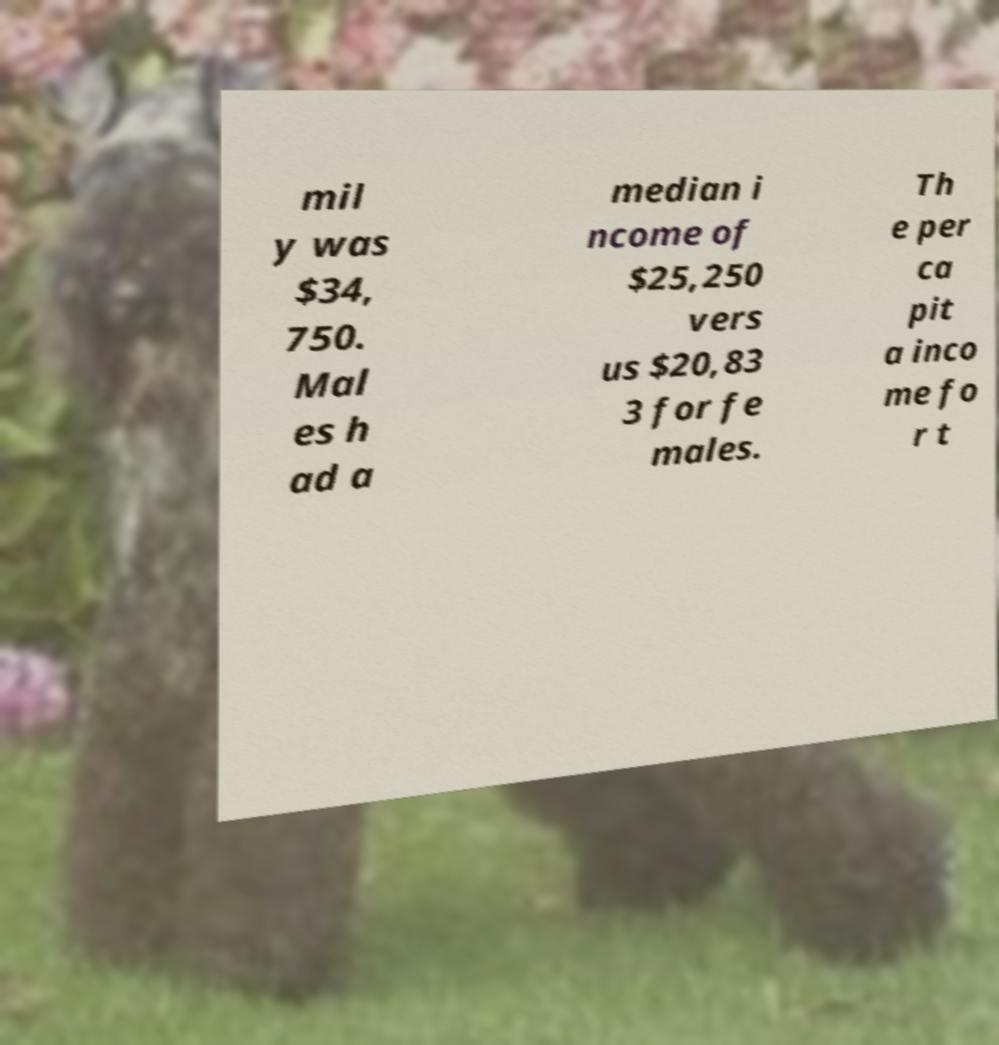What messages or text are displayed in this image? I need them in a readable, typed format. mil y was $34, 750. Mal es h ad a median i ncome of $25,250 vers us $20,83 3 for fe males. Th e per ca pit a inco me fo r t 